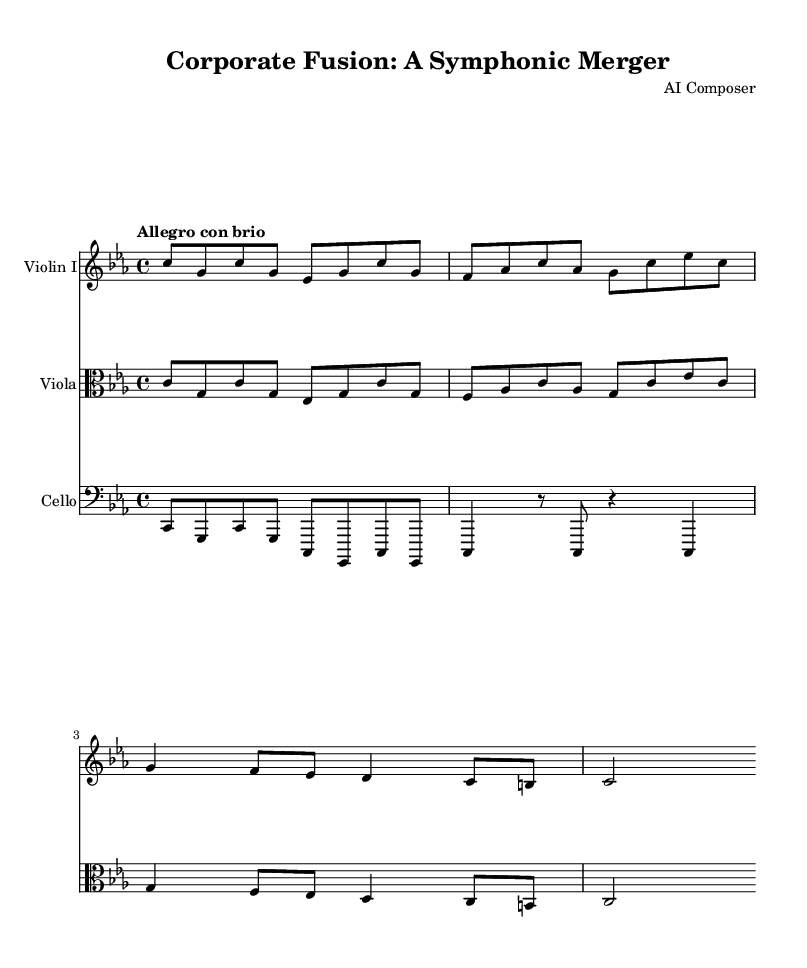What is the key signature of this music? The key signature indicates a C minor scale, which has three flats (B flat, E flat, and A flat). This is represented in the music sheet at the beginning where the key signature appears.
Answer: C minor What is the time signature of the piece? The time signature is 4/4, which means there are four beats in a measure and a quarter note receives one beat. This can be seen at the beginning of the music where the time signature is displayed.
Answer: 4/4 What tempo marking is used in the sheet music? The tempo marking "Allegro con brio" suggests a fast and lively pace, which can be found on the sheet music, indicating the intended speed for performance.
Answer: Allegro con brio How many measures are presented in the score? Counting the distinct groups of notes, there are eight measures presented in the score, as defined by the bar lines.
Answer: Eight What instruments are featured in this symphonic piece? The instruments listed in the score include Violin I, Viola, and Cello, which can be identified in the staff labels above each respective part in the sheet music.
Answer: Violin I, Viola, Cello Which clef is used for the viola part? The viola part is written in the alto clef, which can be identified by the clef symbol displayed at the beginning of the viola staff within the sheet music.
Answer: Alto clef What dynamic level could be implied from the tempo marking? The tempo marking "Allegro con brio" usually implies a strong and lively dynamic, suggesting a potentially loud or intense performance. This can be inferred from the characteristics of the term itself.
Answer: Loud 